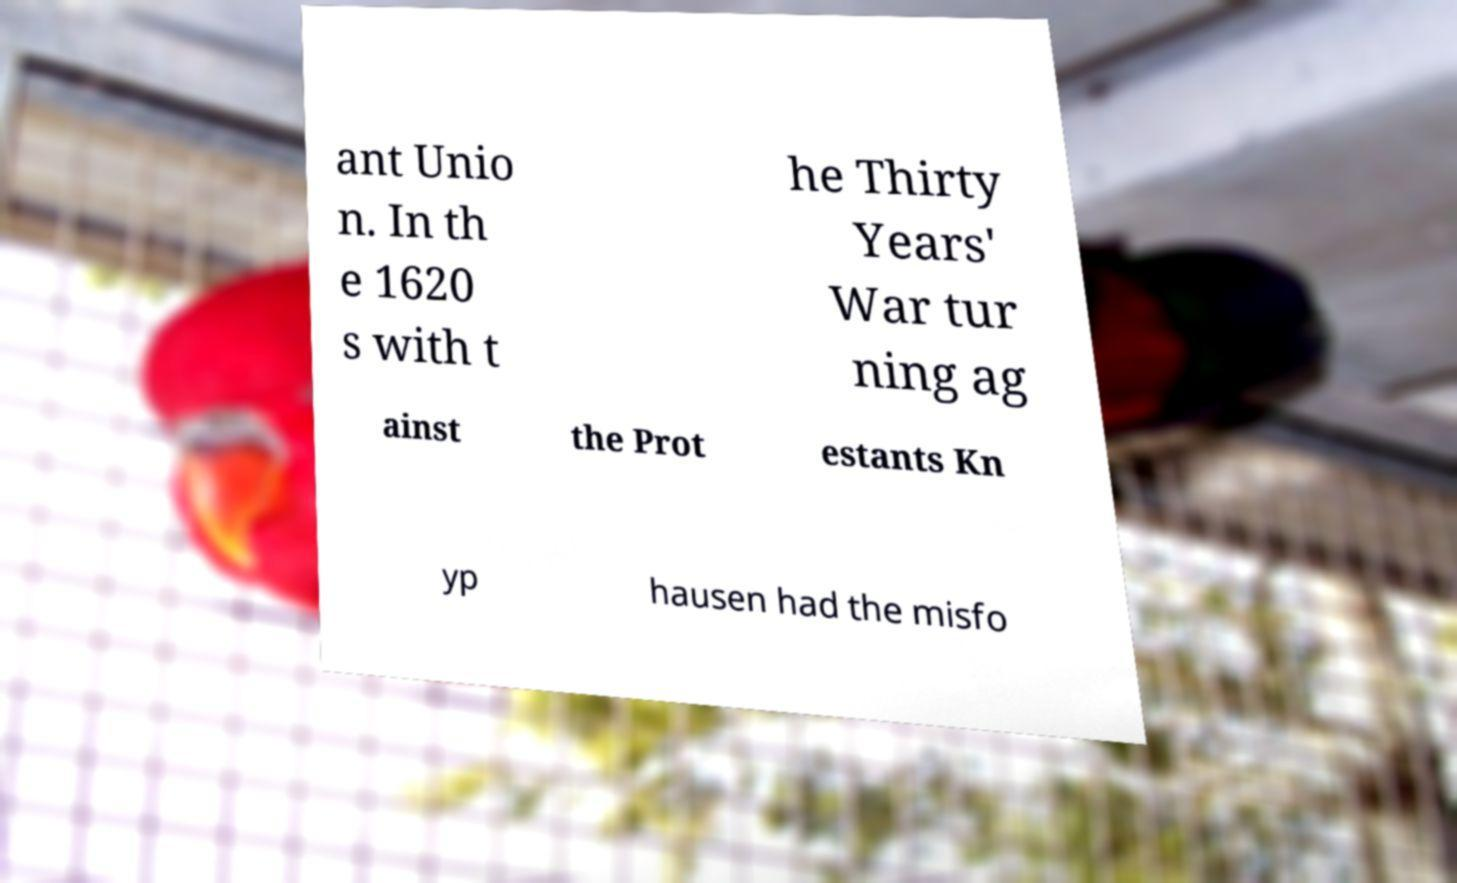Could you assist in decoding the text presented in this image and type it out clearly? ant Unio n. In th e 1620 s with t he Thirty Years' War tur ning ag ainst the Prot estants Kn yp hausen had the misfo 